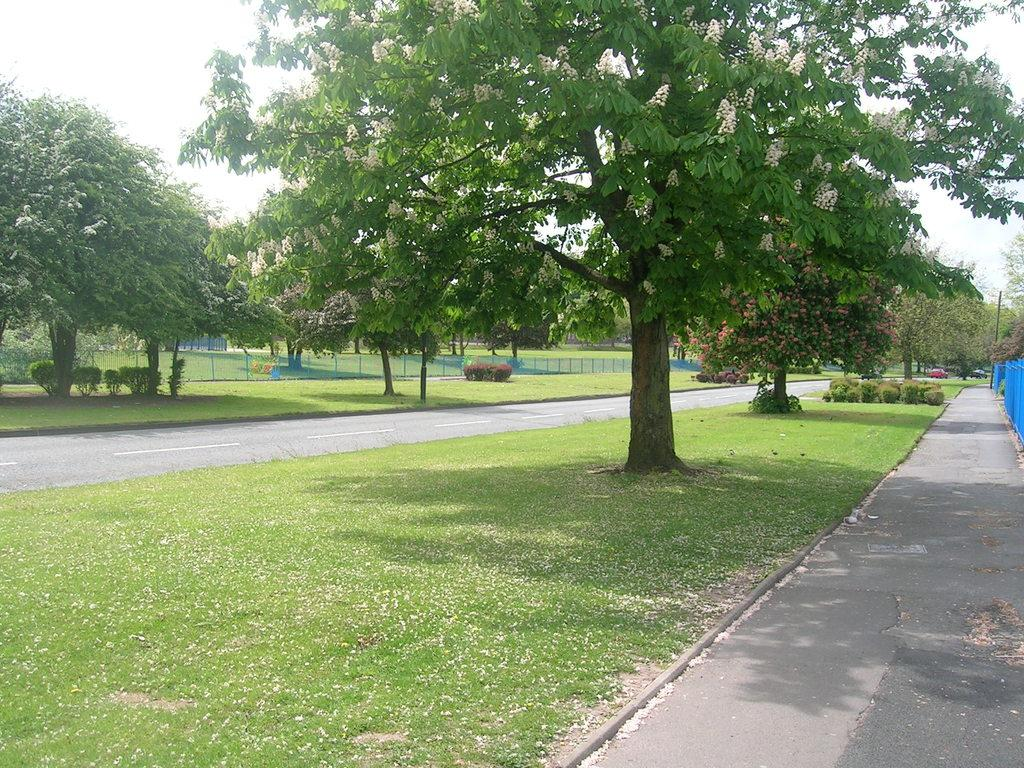What type of vegetation can be seen in the image? There is a group of trees with flowers in the image. What type of structure is present in the image? There is a fence in the image. What type of transportation is visible in the image? A vehicle is visible in the image. What type of surface is present in the image? The road is present in the image. What type of ground cover is present in the image? Grass is present in the image. What other type of vegetation is present in the image? There are plants in the image. What other structures are visible in the image? Poles are visible in the image. What is visible in the sky in the image? The sky is visible in the image, and it appears to be cloudy. How many beginner snakes are crawling on the horse in the image? There is no horse or snakes present in the image. What type of horse is visible in the image? There is no horse present in the image. 